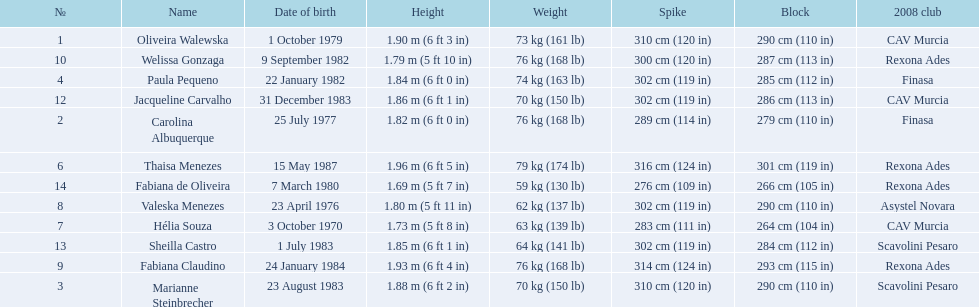Help me parse the entirety of this table. {'header': ['№', 'Name', 'Date of birth', 'Height', 'Weight', 'Spike', 'Block', '2008 club'], 'rows': [['1', 'Oliveira Walewska', '1 October 1979', '1.90\xa0m (6\xa0ft 3\xa0in)', '73\xa0kg (161\xa0lb)', '310\xa0cm (120\xa0in)', '290\xa0cm (110\xa0in)', 'CAV Murcia'], ['10', 'Welissa Gonzaga', '9 September 1982', '1.79\xa0m (5\xa0ft 10\xa0in)', '76\xa0kg (168\xa0lb)', '300\xa0cm (120\xa0in)', '287\xa0cm (113\xa0in)', 'Rexona Ades'], ['4', 'Paula Pequeno', '22 January 1982', '1.84\xa0m (6\xa0ft 0\xa0in)', '74\xa0kg (163\xa0lb)', '302\xa0cm (119\xa0in)', '285\xa0cm (112\xa0in)', 'Finasa'], ['12', 'Jacqueline Carvalho', '31 December 1983', '1.86\xa0m (6\xa0ft 1\xa0in)', '70\xa0kg (150\xa0lb)', '302\xa0cm (119\xa0in)', '286\xa0cm (113\xa0in)', 'CAV Murcia'], ['2', 'Carolina Albuquerque', '25 July 1977', '1.82\xa0m (6\xa0ft 0\xa0in)', '76\xa0kg (168\xa0lb)', '289\xa0cm (114\xa0in)', '279\xa0cm (110\xa0in)', 'Finasa'], ['6', 'Thaisa Menezes', '15 May 1987', '1.96\xa0m (6\xa0ft 5\xa0in)', '79\xa0kg (174\xa0lb)', '316\xa0cm (124\xa0in)', '301\xa0cm (119\xa0in)', 'Rexona Ades'], ['14', 'Fabiana de Oliveira', '7 March 1980', '1.69\xa0m (5\xa0ft 7\xa0in)', '59\xa0kg (130\xa0lb)', '276\xa0cm (109\xa0in)', '266\xa0cm (105\xa0in)', 'Rexona Ades'], ['8', 'Valeska Menezes', '23 April 1976', '1.80\xa0m (5\xa0ft 11\xa0in)', '62\xa0kg (137\xa0lb)', '302\xa0cm (119\xa0in)', '290\xa0cm (110\xa0in)', 'Asystel Novara'], ['7', 'Hélia Souza', '3 October 1970', '1.73\xa0m (5\xa0ft 8\xa0in)', '63\xa0kg (139\xa0lb)', '283\xa0cm (111\xa0in)', '264\xa0cm (104\xa0in)', 'CAV Murcia'], ['13', 'Sheilla Castro', '1 July 1983', '1.85\xa0m (6\xa0ft 1\xa0in)', '64\xa0kg (141\xa0lb)', '302\xa0cm (119\xa0in)', '284\xa0cm (112\xa0in)', 'Scavolini Pesaro'], ['9', 'Fabiana Claudino', '24 January 1984', '1.93\xa0m (6\xa0ft 4\xa0in)', '76\xa0kg (168\xa0lb)', '314\xa0cm (124\xa0in)', '293\xa0cm (115\xa0in)', 'Rexona Ades'], ['3', 'Marianne Steinbrecher', '23 August 1983', '1.88\xa0m (6\xa0ft 2\xa0in)', '70\xa0kg (150\xa0lb)', '310\xa0cm (120\xa0in)', '290\xa0cm (110\xa0in)', 'Scavolini Pesaro']]} Who played during the brazil at the 2008 summer olympics event? Oliveira Walewska, Carolina Albuquerque, Marianne Steinbrecher, Paula Pequeno, Thaisa Menezes, Hélia Souza, Valeska Menezes, Fabiana Claudino, Welissa Gonzaga, Jacqueline Carvalho, Sheilla Castro, Fabiana de Oliveira. And what was the recorded height of each player? 1.90 m (6 ft 3 in), 1.82 m (6 ft 0 in), 1.88 m (6 ft 2 in), 1.84 m (6 ft 0 in), 1.96 m (6 ft 5 in), 1.73 m (5 ft 8 in), 1.80 m (5 ft 11 in), 1.93 m (6 ft 4 in), 1.79 m (5 ft 10 in), 1.86 m (6 ft 1 in), 1.85 m (6 ft 1 in), 1.69 m (5 ft 7 in). Of those, which player is the shortest? Fabiana de Oliveira. 